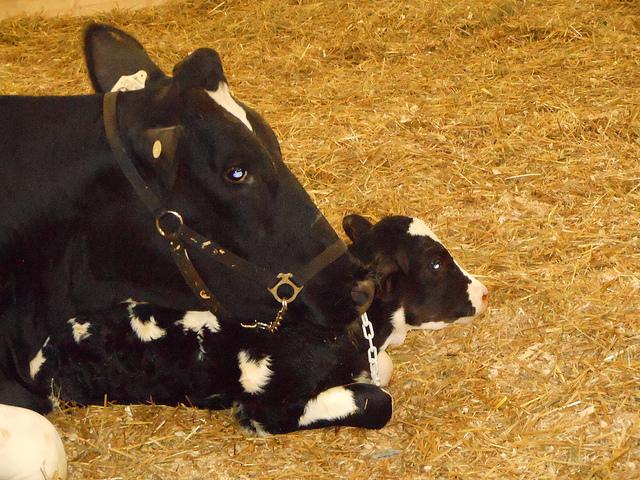How many cows are there?
Be succinct. 2. What are the cows laying on?
Concise answer only. Hay. Are the cows outside?
Give a very brief answer. No. 